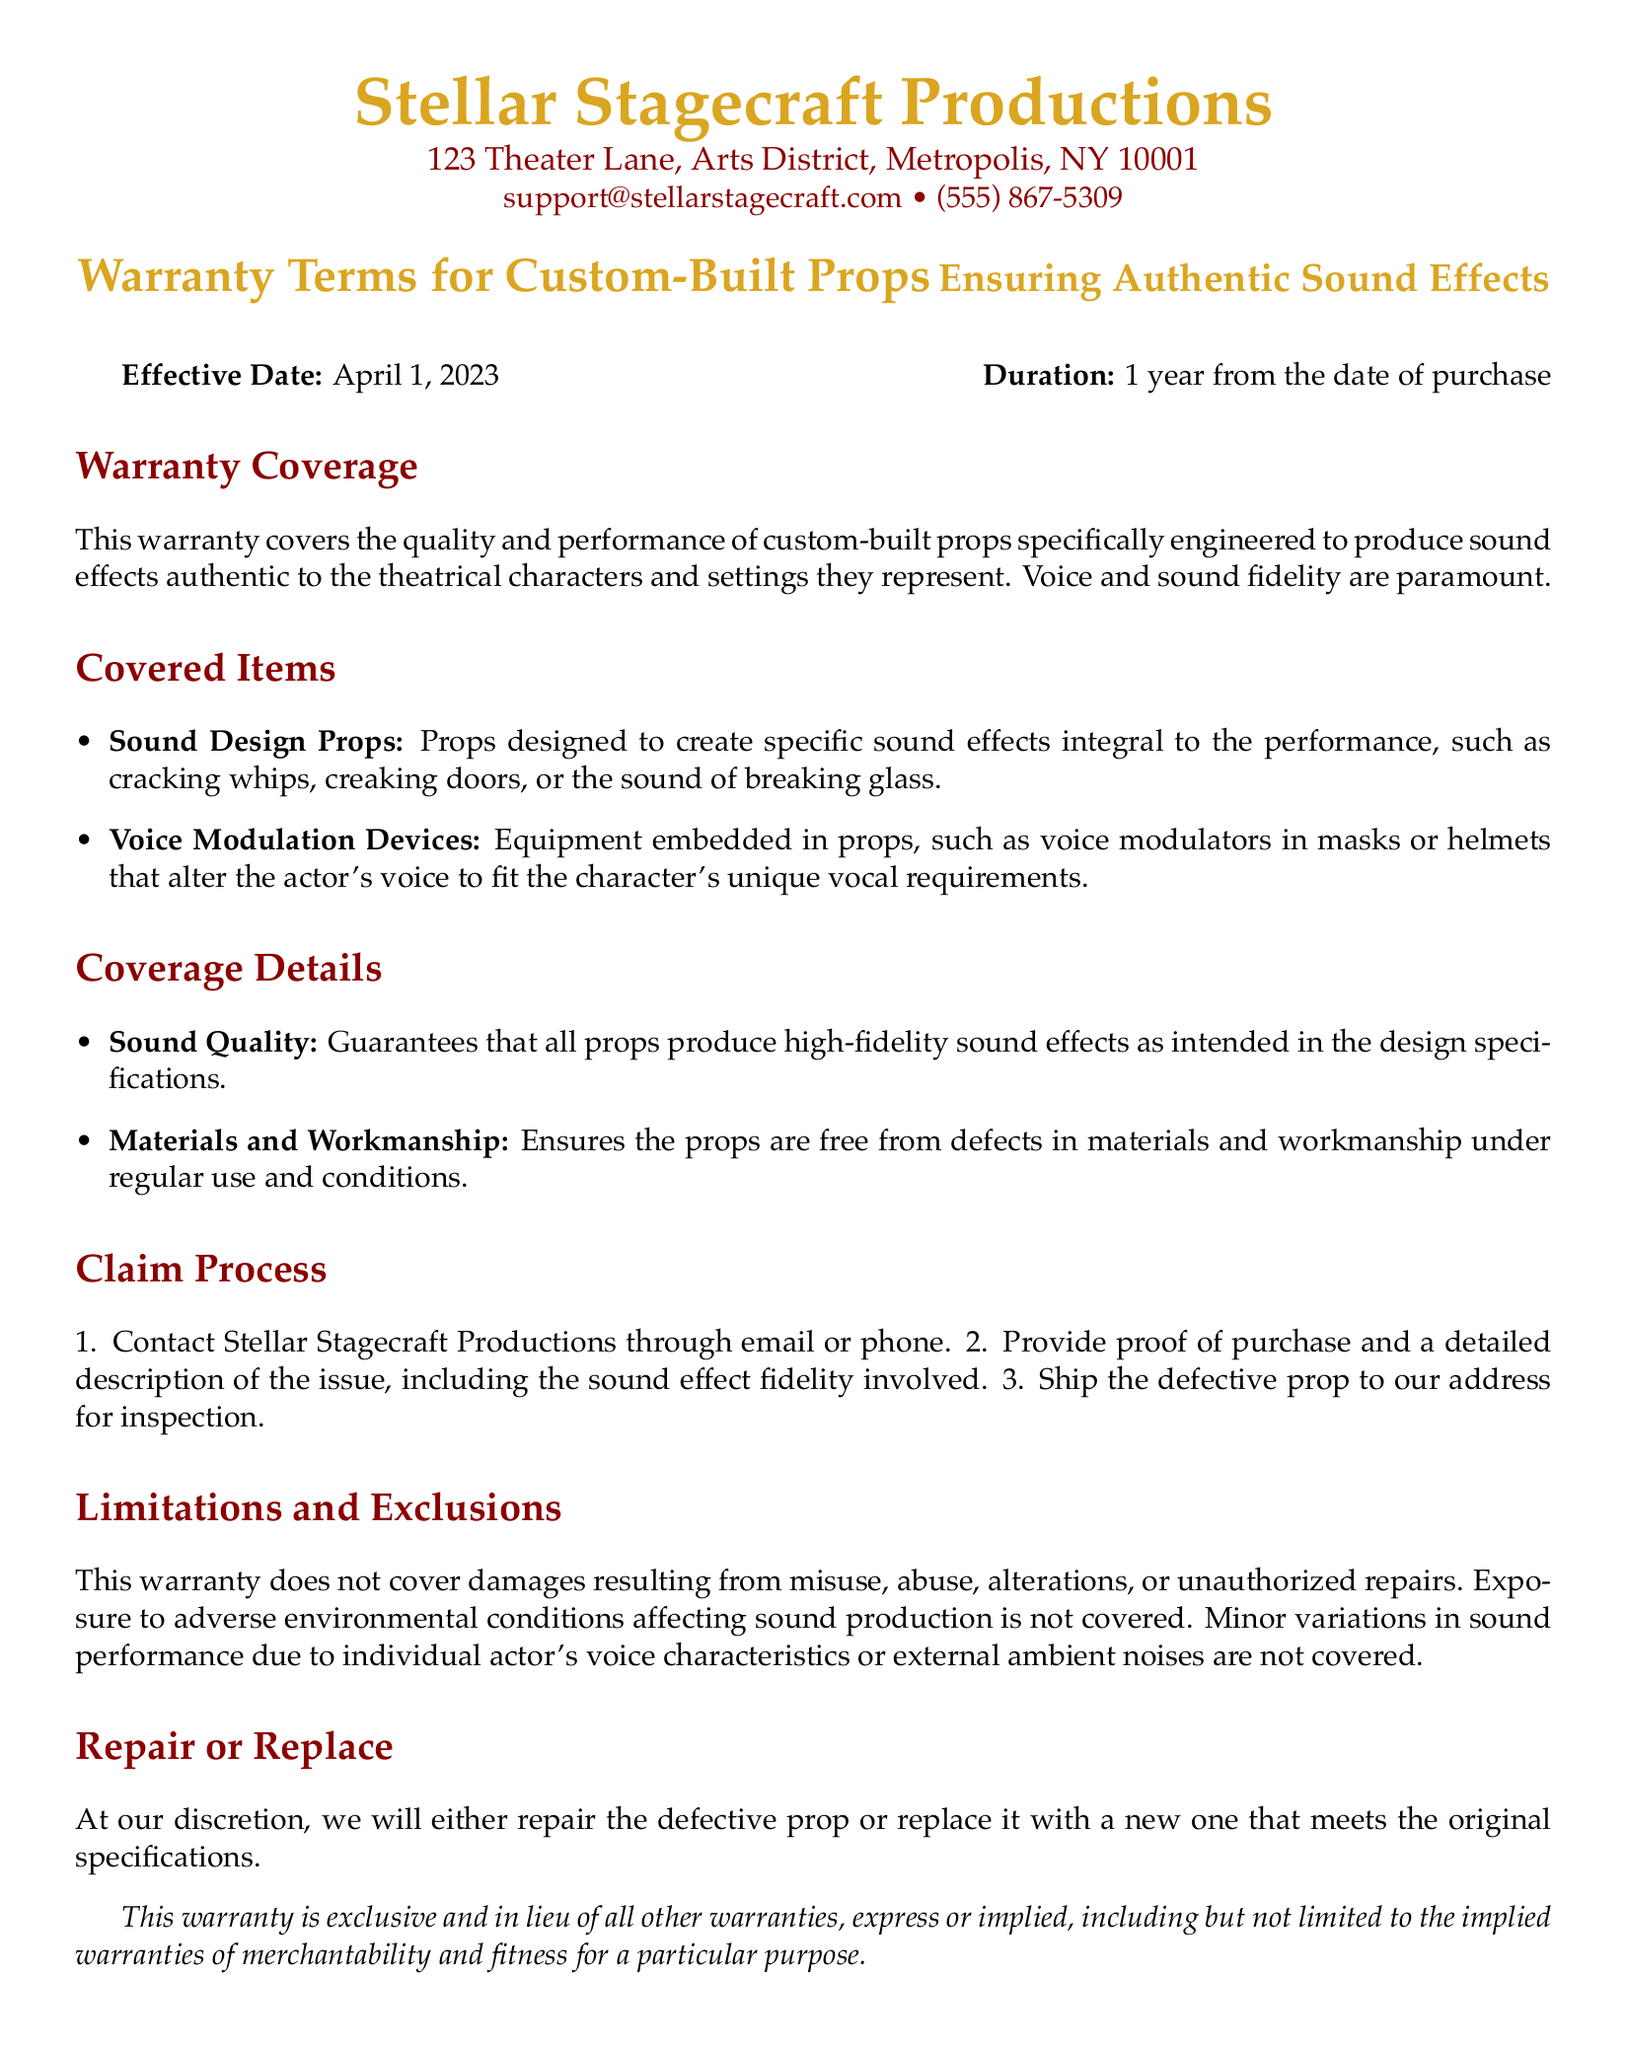What is the effective date of the warranty? The effective date of the warranty is stated in the document, which is April 1, 2023.
Answer: April 1, 2023 What is the duration of the warranty? The duration of the warranty is specified directly in the document as 1 year from the date of purchase.
Answer: 1 year What type of props does this warranty cover? The warranty coverage includes sound design props and voice modulation devices, as listed in the document.
Answer: Sound Design Props, Voice Modulation Devices What must be provided to claim the warranty? The claim process requires proof of purchase and a detailed description of the issue, including sound effect fidelity.
Answer: Proof of purchase, detailed description What type of defects does the warranty cover? The warranty ensures that the props are free from defects in materials and workmanship under regular use and conditions.
Answer: Defects in materials and workmanship What is the contact information for Stellar Stagecraft Productions? The document lists the contact information for Stellar Stagecraft Productions, including email and phone number.
Answer: support@stellarstagecraft.com, (555) 867-5309 How are defective props handled under this warranty? The document states that at their discretion, they will either repair or replace the defective prop to meet original specifications.
Answer: Repair or replace Are environmental conditions covered under the warranty? The limitations section of the document clearly states that exposure to adverse environmental conditions affecting sound production is not covered.
Answer: Not covered 